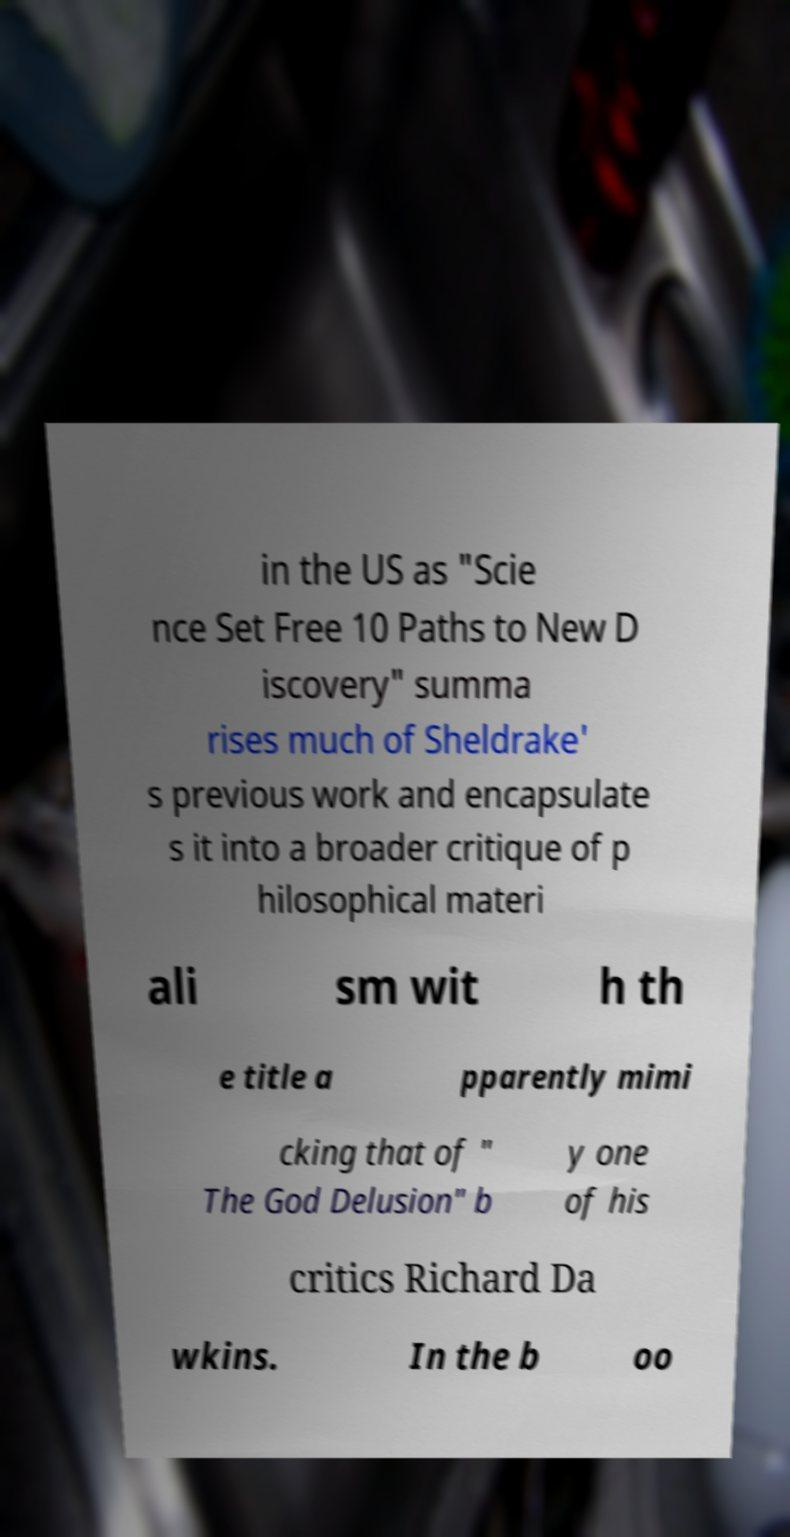For documentation purposes, I need the text within this image transcribed. Could you provide that? in the US as "Scie nce Set Free 10 Paths to New D iscovery" summa rises much of Sheldrake' s previous work and encapsulate s it into a broader critique of p hilosophical materi ali sm wit h th e title a pparently mimi cking that of " The God Delusion" b y one of his critics Richard Da wkins. In the b oo 